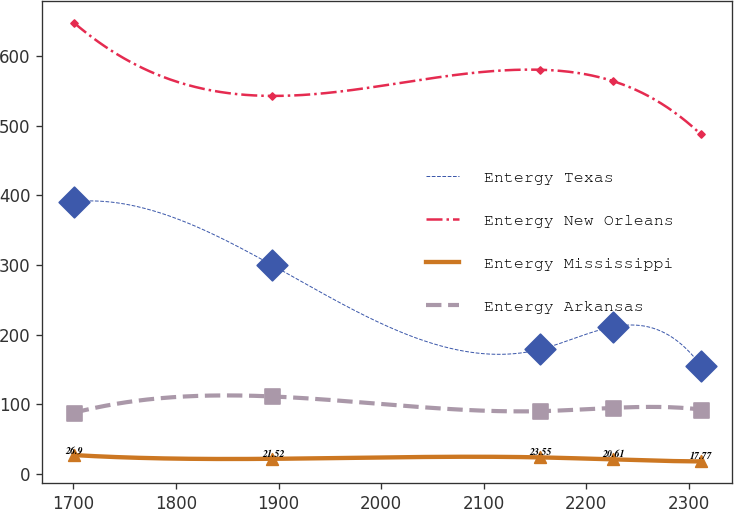Convert chart. <chart><loc_0><loc_0><loc_500><loc_500><line_chart><ecel><fcel>Entergy Texas<fcel>Entergy New Orleans<fcel>Entergy Mississippi<fcel>Entergy Arkansas<nl><fcel>1700.29<fcel>390.81<fcel>647.96<fcel>26.9<fcel>87.58<nl><fcel>1894.02<fcel>299.43<fcel>542.65<fcel>21.52<fcel>111.04<nl><fcel>2154.95<fcel>178.69<fcel>580.19<fcel>23.55<fcel>89.93<nl><fcel>2225.51<fcel>210.89<fcel>564.12<fcel>20.61<fcel>94.63<nl><fcel>2311.82<fcel>155.12<fcel>487.23<fcel>17.77<fcel>92.28<nl></chart> 